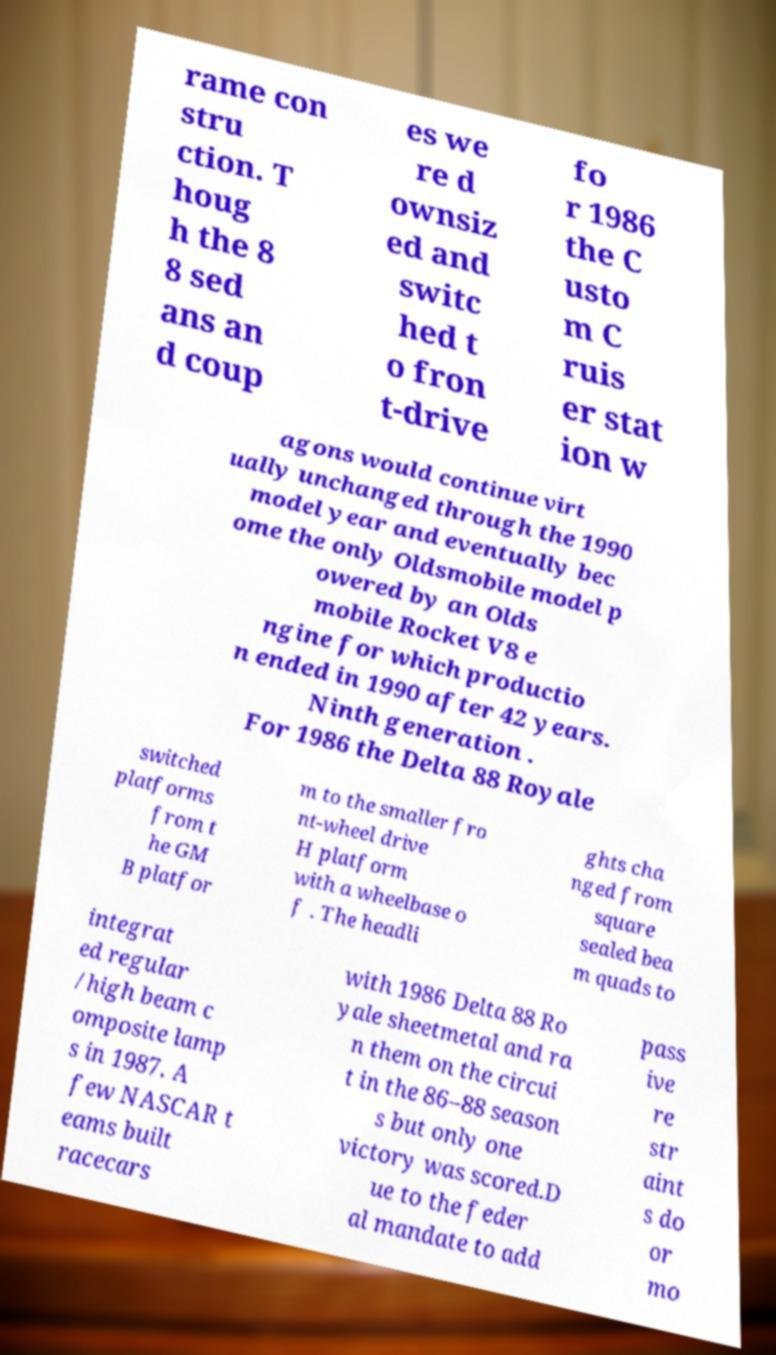I need the written content from this picture converted into text. Can you do that? rame con stru ction. T houg h the 8 8 sed ans an d coup es we re d ownsiz ed and switc hed t o fron t-drive fo r 1986 the C usto m C ruis er stat ion w agons would continue virt ually unchanged through the 1990 model year and eventually bec ome the only Oldsmobile model p owered by an Olds mobile Rocket V8 e ngine for which productio n ended in 1990 after 42 years. Ninth generation . For 1986 the Delta 88 Royale switched platforms from t he GM B platfor m to the smaller fro nt-wheel drive H platform with a wheelbase o f . The headli ghts cha nged from square sealed bea m quads to integrat ed regular /high beam c omposite lamp s in 1987. A few NASCAR t eams built racecars with 1986 Delta 88 Ro yale sheetmetal and ra n them on the circui t in the 86–88 season s but only one victory was scored.D ue to the feder al mandate to add pass ive re str aint s do or mo 